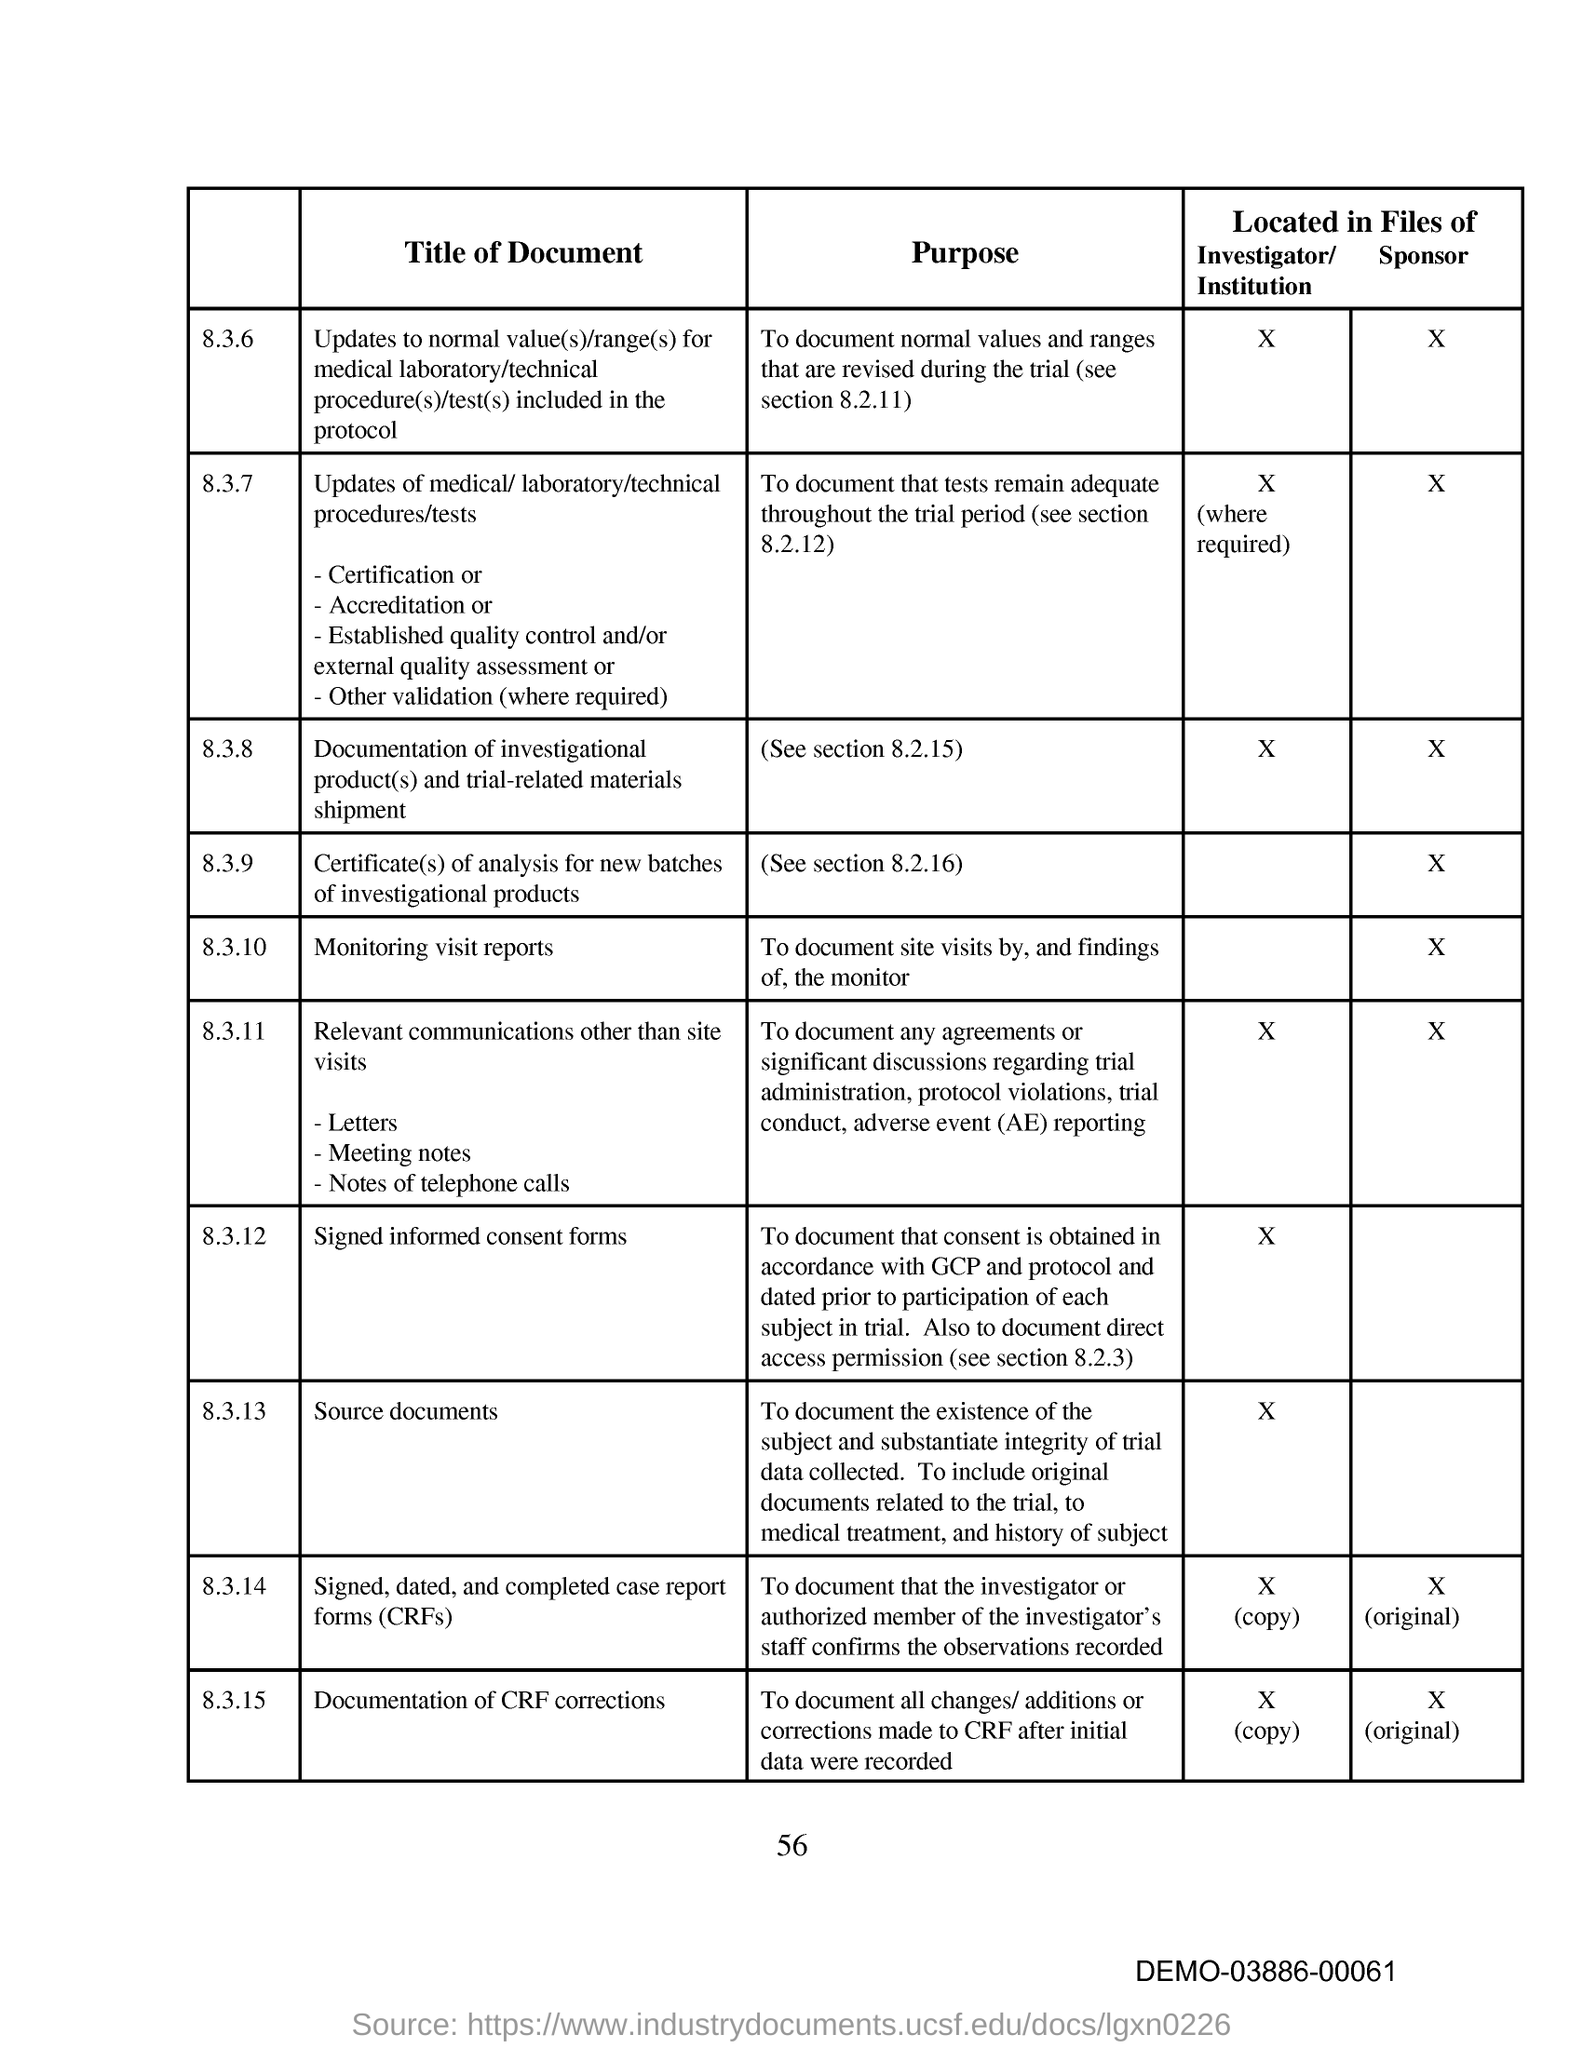Identify some key points in this picture. The purpose of section 8.3.10 is to document site visits by and findings of the monitor. The page number on this document is 56. The bottom right corner of the page contains a code with the text 'DEMO-03886-00061...'. 